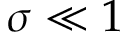Convert formula to latex. <formula><loc_0><loc_0><loc_500><loc_500>\sigma \ll 1</formula> 